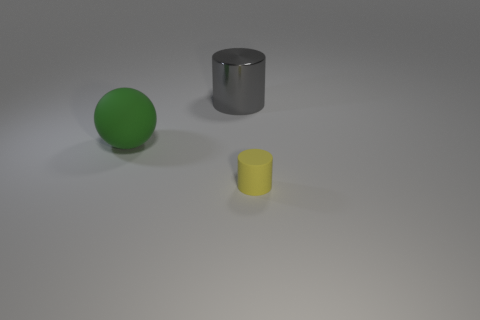Subtract all yellow spheres. Subtract all purple cubes. How many spheres are left? 1 Subtract all purple cubes. How many cyan spheres are left? 0 Add 3 large grays. How many big objects exist? 0 Subtract all gray things. Subtract all big red matte cylinders. How many objects are left? 2 Add 1 large green things. How many large green things are left? 2 Add 3 yellow matte things. How many yellow matte things exist? 4 Add 1 large brown things. How many objects exist? 4 Subtract all gray cylinders. How many cylinders are left? 1 Subtract 0 brown balls. How many objects are left? 3 Subtract all cylinders. How many objects are left? 1 